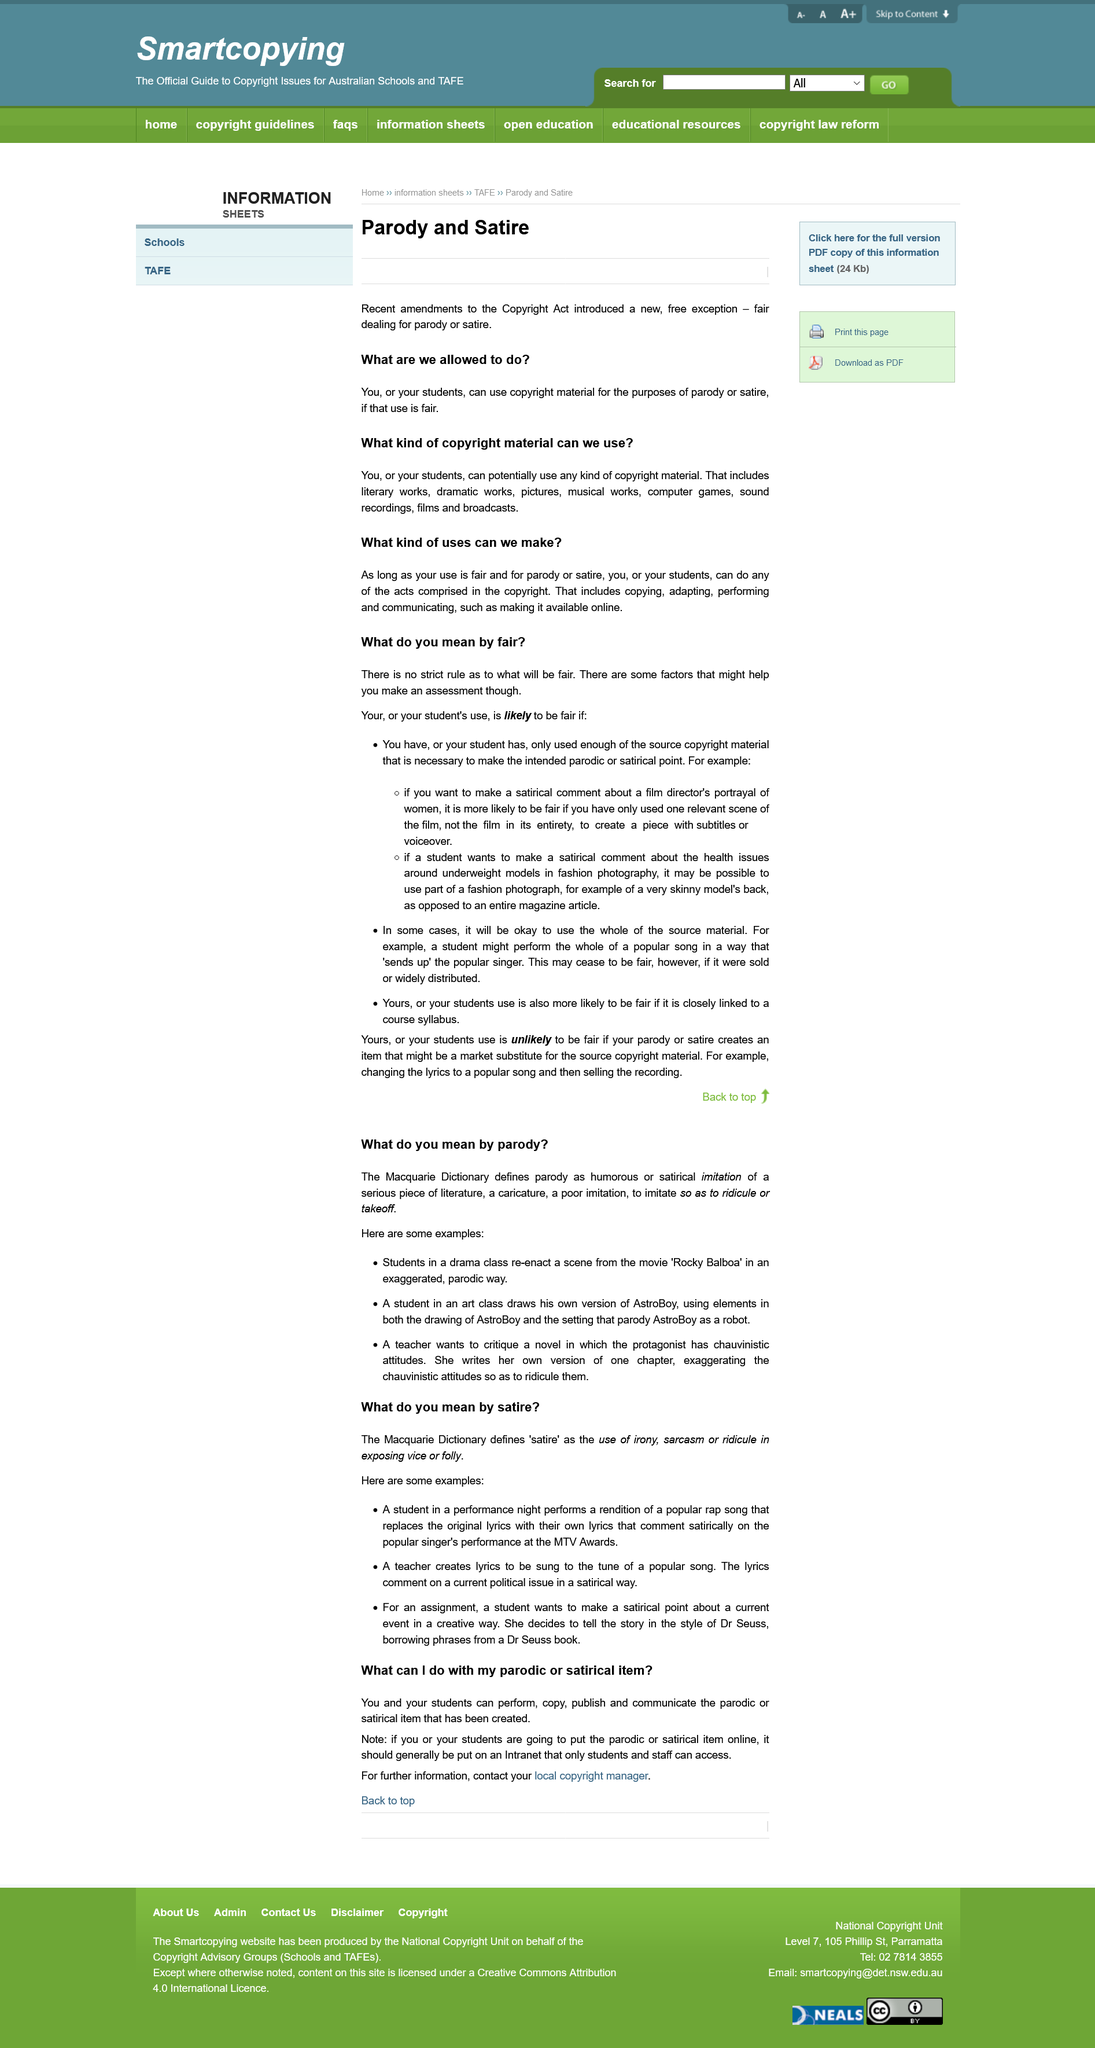Draw attention to some important aspects in this diagram. In the given examples, the student uses the author Dr. Seuss to make a satirical point about the political ideology of capitalism. Using satire, such as a teacher making a lyric to a popular song that comments on a current political issue in a humorous and critical way, is a common example of its utilization. There are no strict rules to follow when deciding what is fair. When is something's use likely to be fair? The use of a source copyright material is deemed fair when it is only used to the extent necessary to make the intended periodic or satirical point, and no more. Using only one relevant scene from a film to make a satirical comment regarding a film director's portrayal of women is likely to be fair, as long as the context and purpose of the use are considered. 